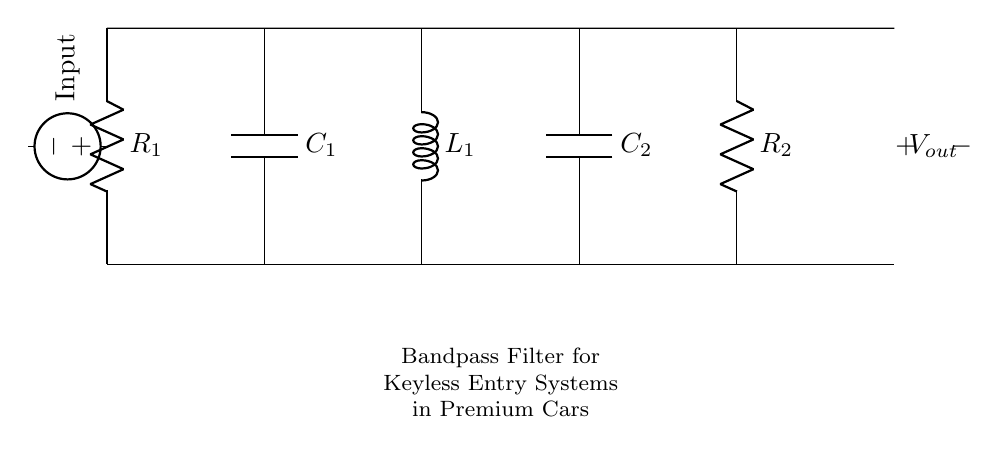What is the type of filter represented in this circuit? The circuit diagram depicts a bandpass filter, which is designed to allow a specific range of frequencies to pass while blocking frequencies outside this range.
Answer: Bandpass filter What components are included in the circuit? The circuit consists of two resistors, two capacitors, and one inductor, which are commonly used in filter designs for frequency selection.
Answer: Resistors, capacitors, inductor What is the role of the inductor in this filter? The inductor in a bandpass filter helps to restrict high-frequency signals while allowing lower frequencies to pass through, contributing to the filter's frequency response characteristic.
Answer: To restrict high frequencies What would happen if the value of C1 is increased? Increasing the capacitance of C1 alters the cut-off frequency of the filter; specifically, it would lower the cutoff frequency, allowing more low frequencies to pass.
Answer: Lower cut-off frequency How many total components are in the circuit? By counting each component listed in the schematic, there are five components: two resistors, two capacitors, and one inductor.
Answer: Five components What is the significance of the input voltage source in this circuit? The input voltage source provides the signal that will be processed by the filter, determining which frequencies are allowed to pass or be attenuated.
Answer: To provide the signal 